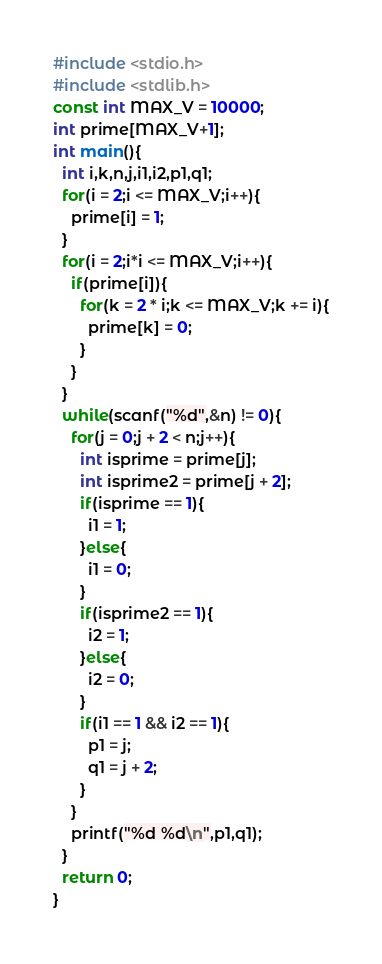Convert code to text. <code><loc_0><loc_0><loc_500><loc_500><_C++_>#include <stdio.h>
#include <stdlib.h>
const int MAX_V = 10000;
int prime[MAX_V+1];
int main(){
  int i,k,n,j,i1,i2,p1,q1;
  for(i = 2;i <= MAX_V;i++){
    prime[i] = 1;
  }
  for(i = 2;i*i <= MAX_V;i++){
    if(prime[i]){
      for(k = 2 * i;k <= MAX_V;k += i){
        prime[k] = 0;
      }
    }
  }
  while(scanf("%d",&n) != 0){
    for(j = 0;j + 2 < n;j++){
      int isprime = prime[j];
      int isprime2 = prime[j + 2];
      if(isprime == 1){
        i1 = 1;
      }else{
        i1 = 0;
      }
      if(isprime2 == 1){
        i2 = 1;
      }else{
        i2 = 0;
      }
      if(i1 == 1 && i2 == 1){ 
        p1 = j;
        q1 = j + 2;
      }
    }
    printf("%d %d\n",p1,q1);
  }
  return 0;
}</code> 